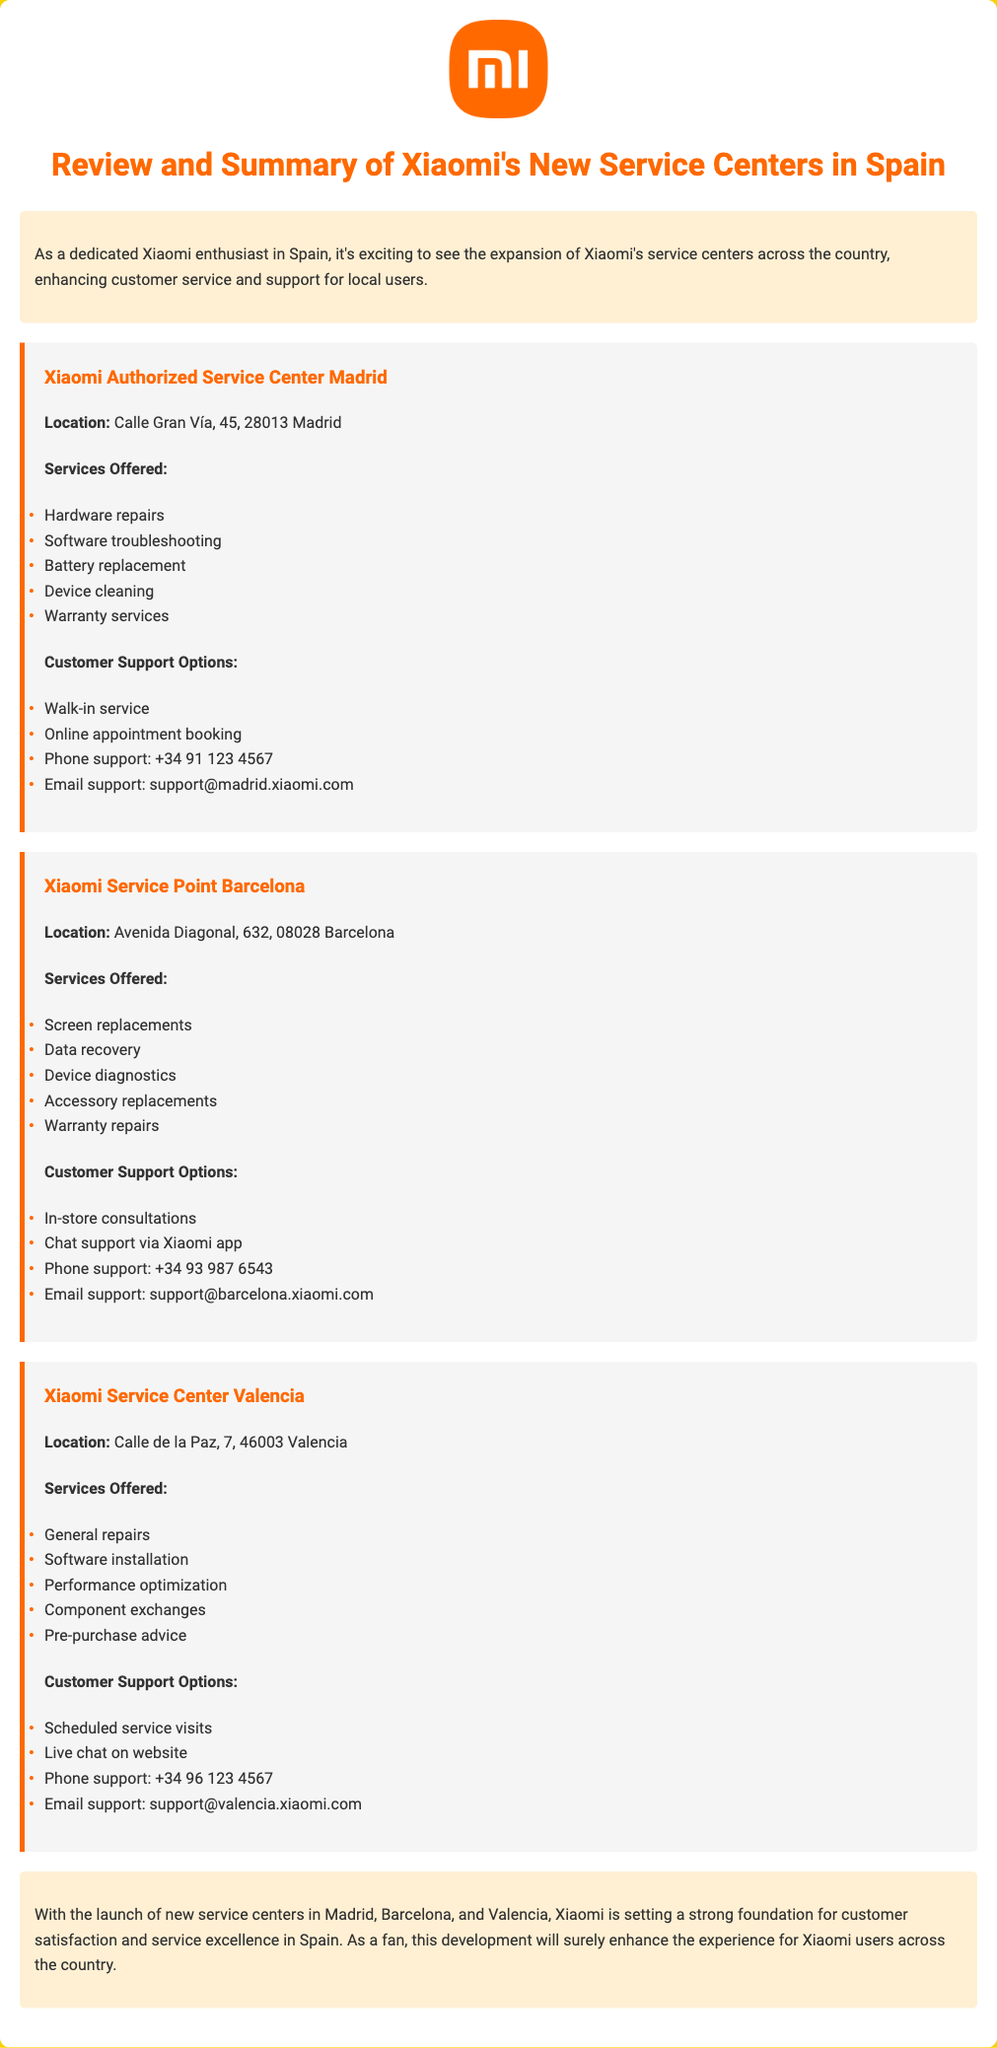what is the location of the Xiaomi Authorized Service Center in Madrid? The location is specifically listed in the document under the service center section.
Answer: Calle Gran Vía, 45, 28013 Madrid what services are offered at the Xiaomi Service Point in Barcelona? The document lists various services provided at this service point.
Answer: Screen replacements, Data recovery, Device diagnostics, Accessory replacements, Warranty repairs what is the phone support number for the Xiaomi Service Center in Valencia? The phone support number is provided in the customer support options section for Valencia.
Answer: +34 96 123 4567 how many service centers are mentioned in the document? The document specifies the number of service centers detailed in the summary.
Answer: 3 what type of support options are available at the Xiaomi Authorized Service Center in Madrid? The document details different customer support options available for this center.
Answer: Walk-in service, Online appointment booking, Phone support, Email support which city has a service point that offers chat support via the Xiaomi app? The document describes the customer support options available at service points and centers.
Answer: Barcelona what is the primary focus of the document? The document is intended to provide a review and summary of new service centers.
Answer: Review and Summary of Xiaomi's New Service Centers in Spain what is a service offered at the Xiaomi Service Center in Valencia? The document lists specific services available at this center as part of its offerings.
Answer: General repairs what is the email support address for the service center in Madrid? The email addresses for customer support are specified in the document under customer support options.
Answer: support@madrid.xiaomi.com 